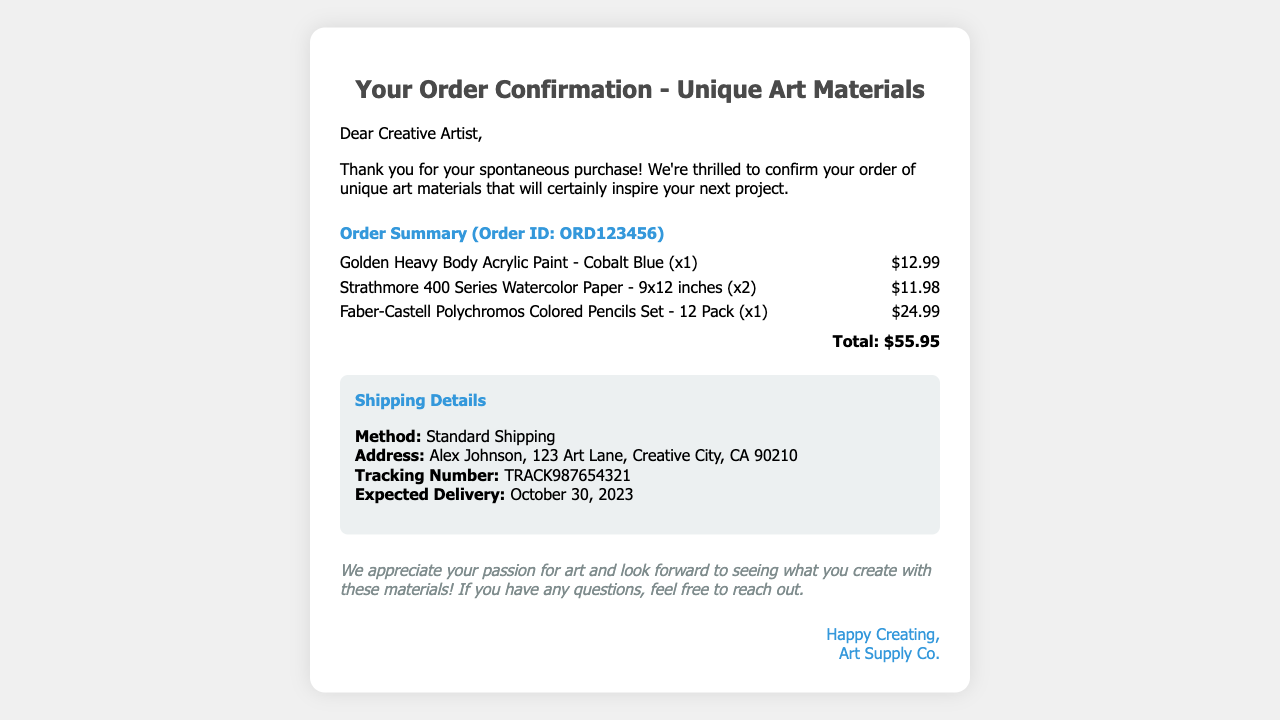What is the order ID? The order ID is explicitly mentioned in the document as ORD123456.
Answer: ORD123456 What items were ordered? The document lists three items ordered: acrylic paint, watercolor paper, and colored pencils.
Answer: Golden Heavy Body Acrylic Paint, Strathmore 400 Series Watercolor Paper, Faber-Castell Polychromos Colored Pencils Set What is the total amount of the order? The total amount is the sum of all item prices, indicated as $55.95 in the document.
Answer: $55.95 Who is the recipient of the order? The recipient's name is provided in the shipping details, identified as Alex Johnson.
Answer: Alex Johnson When is the expected delivery date? The expected delivery date is specified within the shipping details as October 30, 2023.
Answer: October 30, 2023 What shipping method was used? The shipping method is mentioned in the document, specifically labeled as Standard Shipping.
Answer: Standard Shipping How many Strathmore watercolor paper pads were ordered? The document states that two pads of Strathmore 400 Series Watercolor Paper were ordered.
Answer: 2 What is the tracking number for the shipment? The tracking number is given in the shipping details as TRACK987654321.
Answer: TRACK987654321 What is the company name sending the order? The company name is indicated in the closing signature as Art Supply Co.
Answer: Art Supply Co 